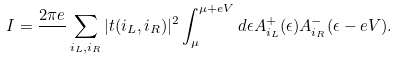<formula> <loc_0><loc_0><loc_500><loc_500>I = \frac { 2 \pi e } { } \sum _ { i _ { L } , i _ { R } } | t ( i _ { L } , i _ { R } ) | ^ { 2 } \int _ { \mu } ^ { \mu + e V } d \epsilon A ^ { + } _ { i _ { L } } ( \epsilon ) A ^ { - } _ { i _ { R } } ( \epsilon - e V ) .</formula> 